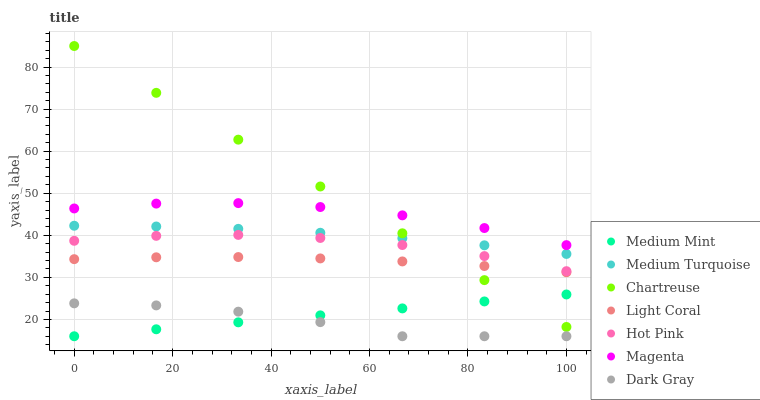Does Dark Gray have the minimum area under the curve?
Answer yes or no. Yes. Does Chartreuse have the maximum area under the curve?
Answer yes or no. Yes. Does Hot Pink have the minimum area under the curve?
Answer yes or no. No. Does Hot Pink have the maximum area under the curve?
Answer yes or no. No. Is Medium Mint the smoothest?
Answer yes or no. Yes. Is Dark Gray the roughest?
Answer yes or no. Yes. Is Hot Pink the smoothest?
Answer yes or no. No. Is Hot Pink the roughest?
Answer yes or no. No. Does Medium Mint have the lowest value?
Answer yes or no. Yes. Does Hot Pink have the lowest value?
Answer yes or no. No. Does Chartreuse have the highest value?
Answer yes or no. Yes. Does Hot Pink have the highest value?
Answer yes or no. No. Is Medium Turquoise less than Magenta?
Answer yes or no. Yes. Is Magenta greater than Dark Gray?
Answer yes or no. Yes. Does Chartreuse intersect Medium Turquoise?
Answer yes or no. Yes. Is Chartreuse less than Medium Turquoise?
Answer yes or no. No. Is Chartreuse greater than Medium Turquoise?
Answer yes or no. No. Does Medium Turquoise intersect Magenta?
Answer yes or no. No. 